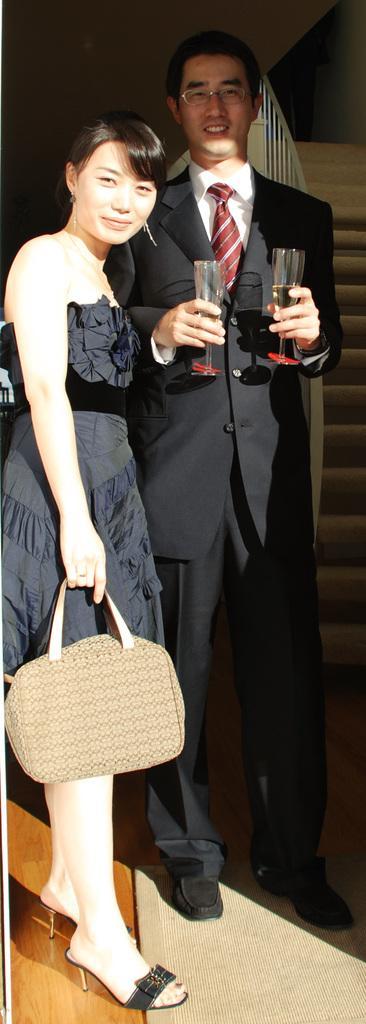How would you summarize this image in a sentence or two? This is the picture of a woman standing and holding a bag in her hand and a man standing and smiling by holding a glass in his hand and the back ground there are the staircases. 